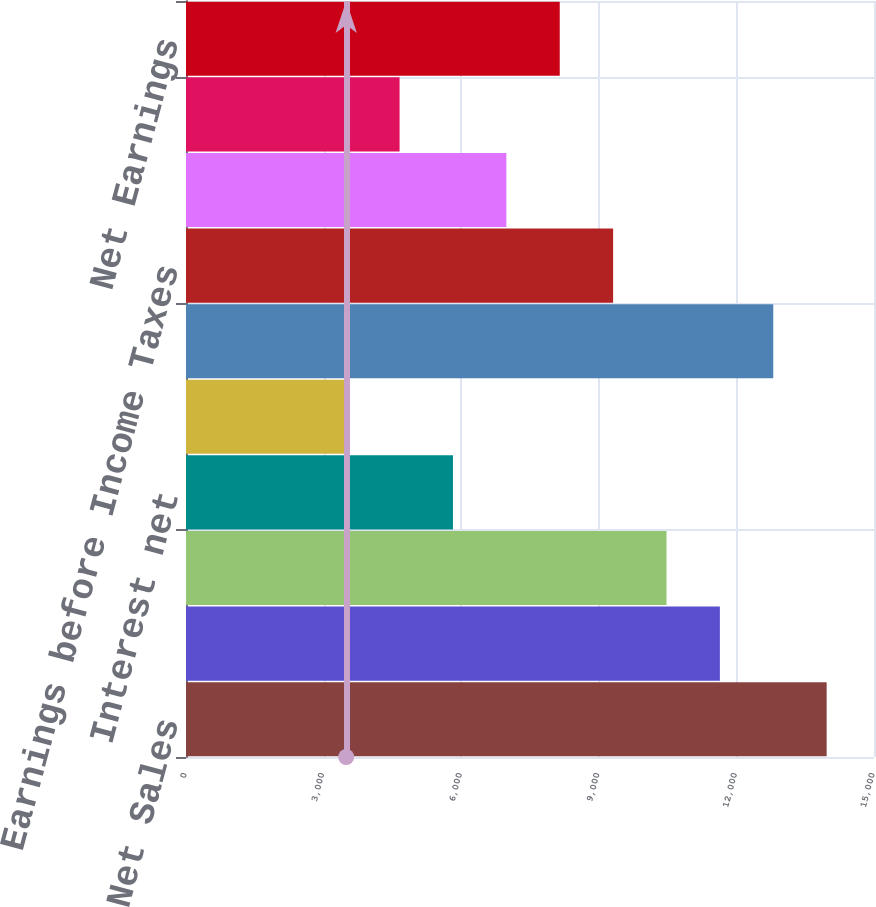Convert chart to OTSL. <chart><loc_0><loc_0><loc_500><loc_500><bar_chart><fcel>Net Sales<fcel>Cost of sales<fcel>Selling general and<fcel>Interest net<fcel>Restructuring and other exit<fcel>Total Costs and Expenses<fcel>Earnings before Income Taxes<fcel>Income Taxes<fcel>After-tax Earnings from Joint<fcel>Net Earnings<nl><fcel>13967.8<fcel>11640<fcel>10476.2<fcel>5820.69<fcel>3492.95<fcel>12803.9<fcel>9312.3<fcel>6984.56<fcel>4656.82<fcel>8148.43<nl></chart> 